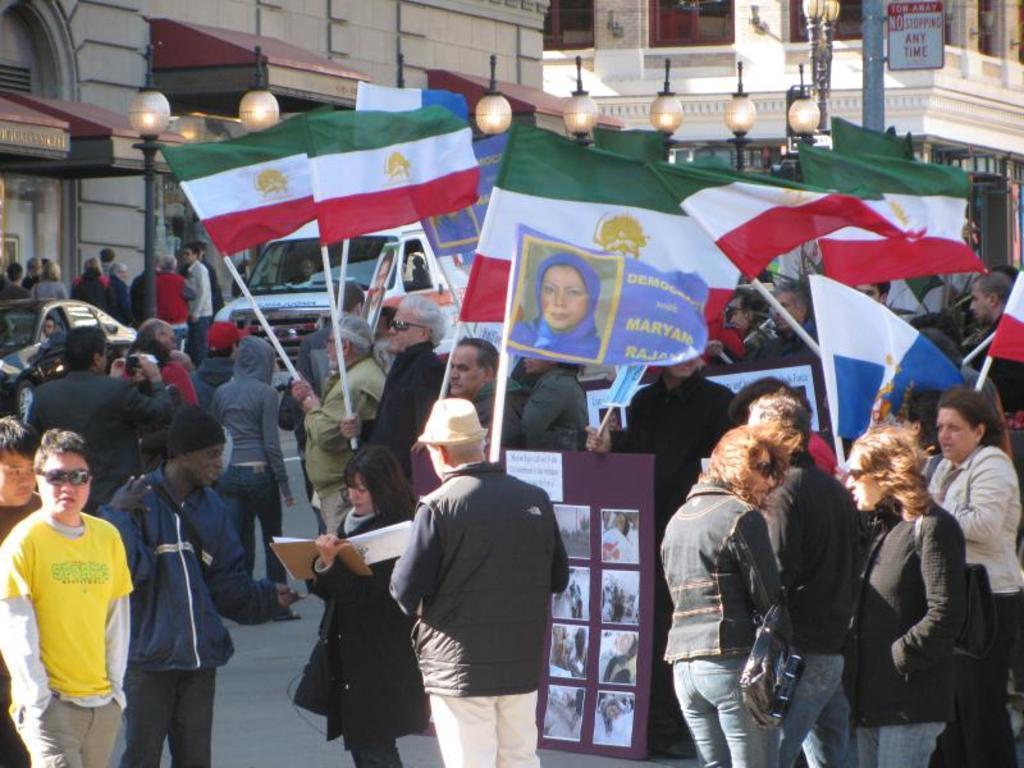Could you give a brief overview of what you see in this image? In this picture we can see group of people and few people holding flags, in the background we can find few lights, poles, buildings and vehicles. 